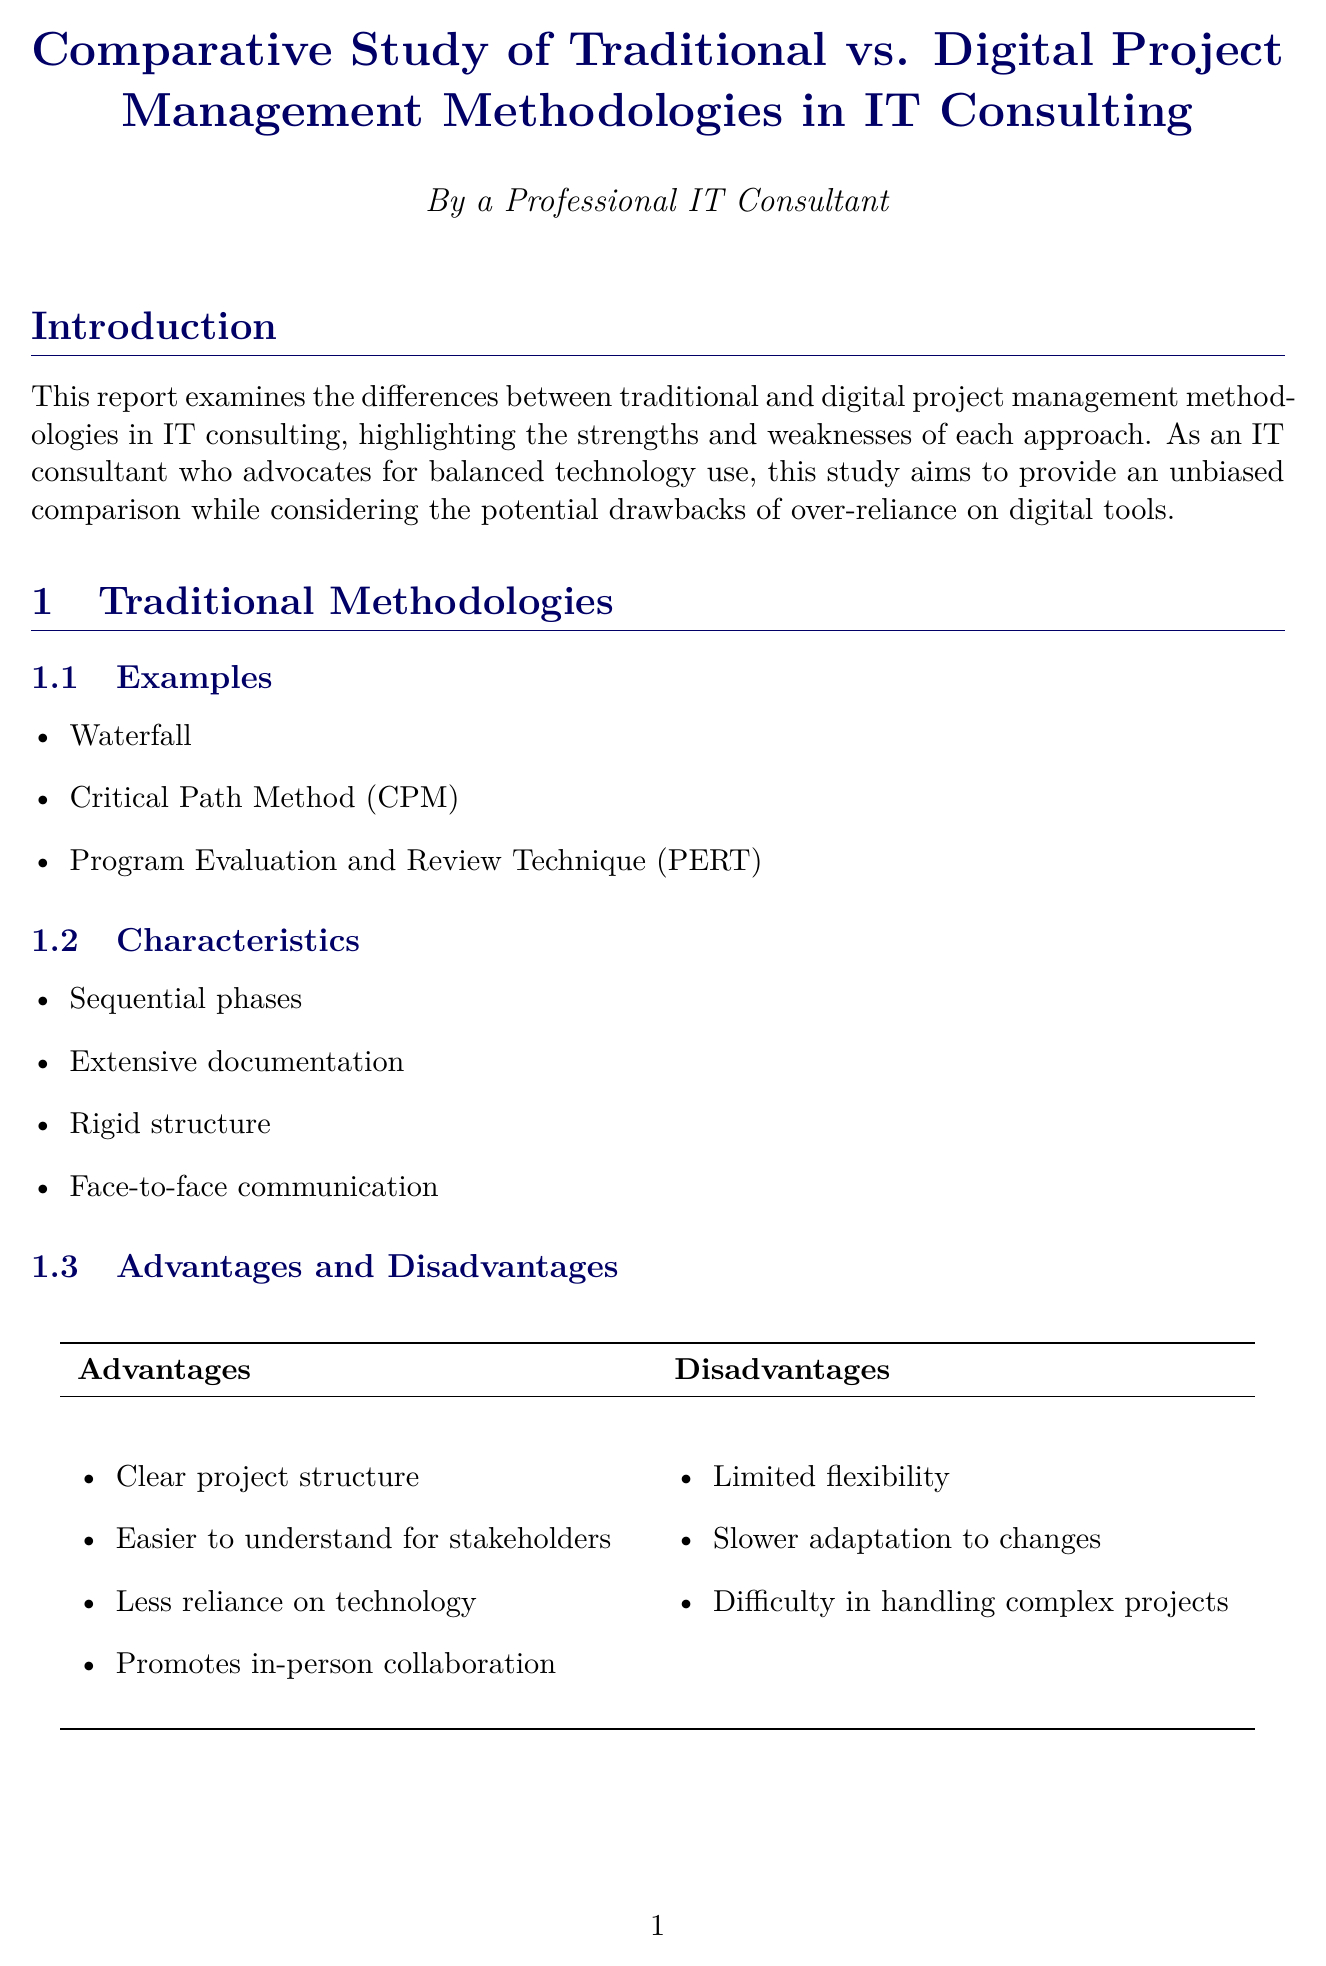What are the traditional methodologies discussed in the report? The report lists several traditional project management methodologies, including Waterfall, Critical Path Method, and Program Evaluation and Review Technique.
Answer: Waterfall, Critical Path Method (CPM), Program Evaluation and Review Technique (PERT) What is one advantage of traditional methodologies? The report outlines advantages of traditional methodologies, which include clear project structure, easier stakeholder understanding, less reliance on technology, and in-person collaboration.
Answer: Clear project structure What company is mentioned in relation to a hybrid project management methodology? The case studies section details projects by different companies, one of which describes Accenture's use of a hybrid methodology.
Answer: Accenture What is a disadvantage of digital methodologies? The report discusses various disadvantages of digital methodologies, including issues related to over-reliance on technology and learning curves for new tools.
Answer: Over-reliance on technology What tool is suggested for traditional project management? The tool comparison section highlights a specific tool used in traditional project management, which helps with planning.
Answer: Microsoft Project How does the report propose to address technology dependence in project management? The recommendations section emphasizes the importance of maintaining a balance and encourages regular assessments of digital tools' effects on productivity.
Answer: Regularly assess the impact of digital tools on team productivity and well-being What is the overall conclusion about project management methodologies? The conclusion summarizes the findings, suggesting that a balanced approach to methodologies can be beneficial for project success.
Answer: Thoughtful combination of both What type of approach is recommended for project management in the report? The recommendations suggest that a specific type of methodology combining elements from both traditional and digital methodologies is ideal.
Answer: Hybrid approach 